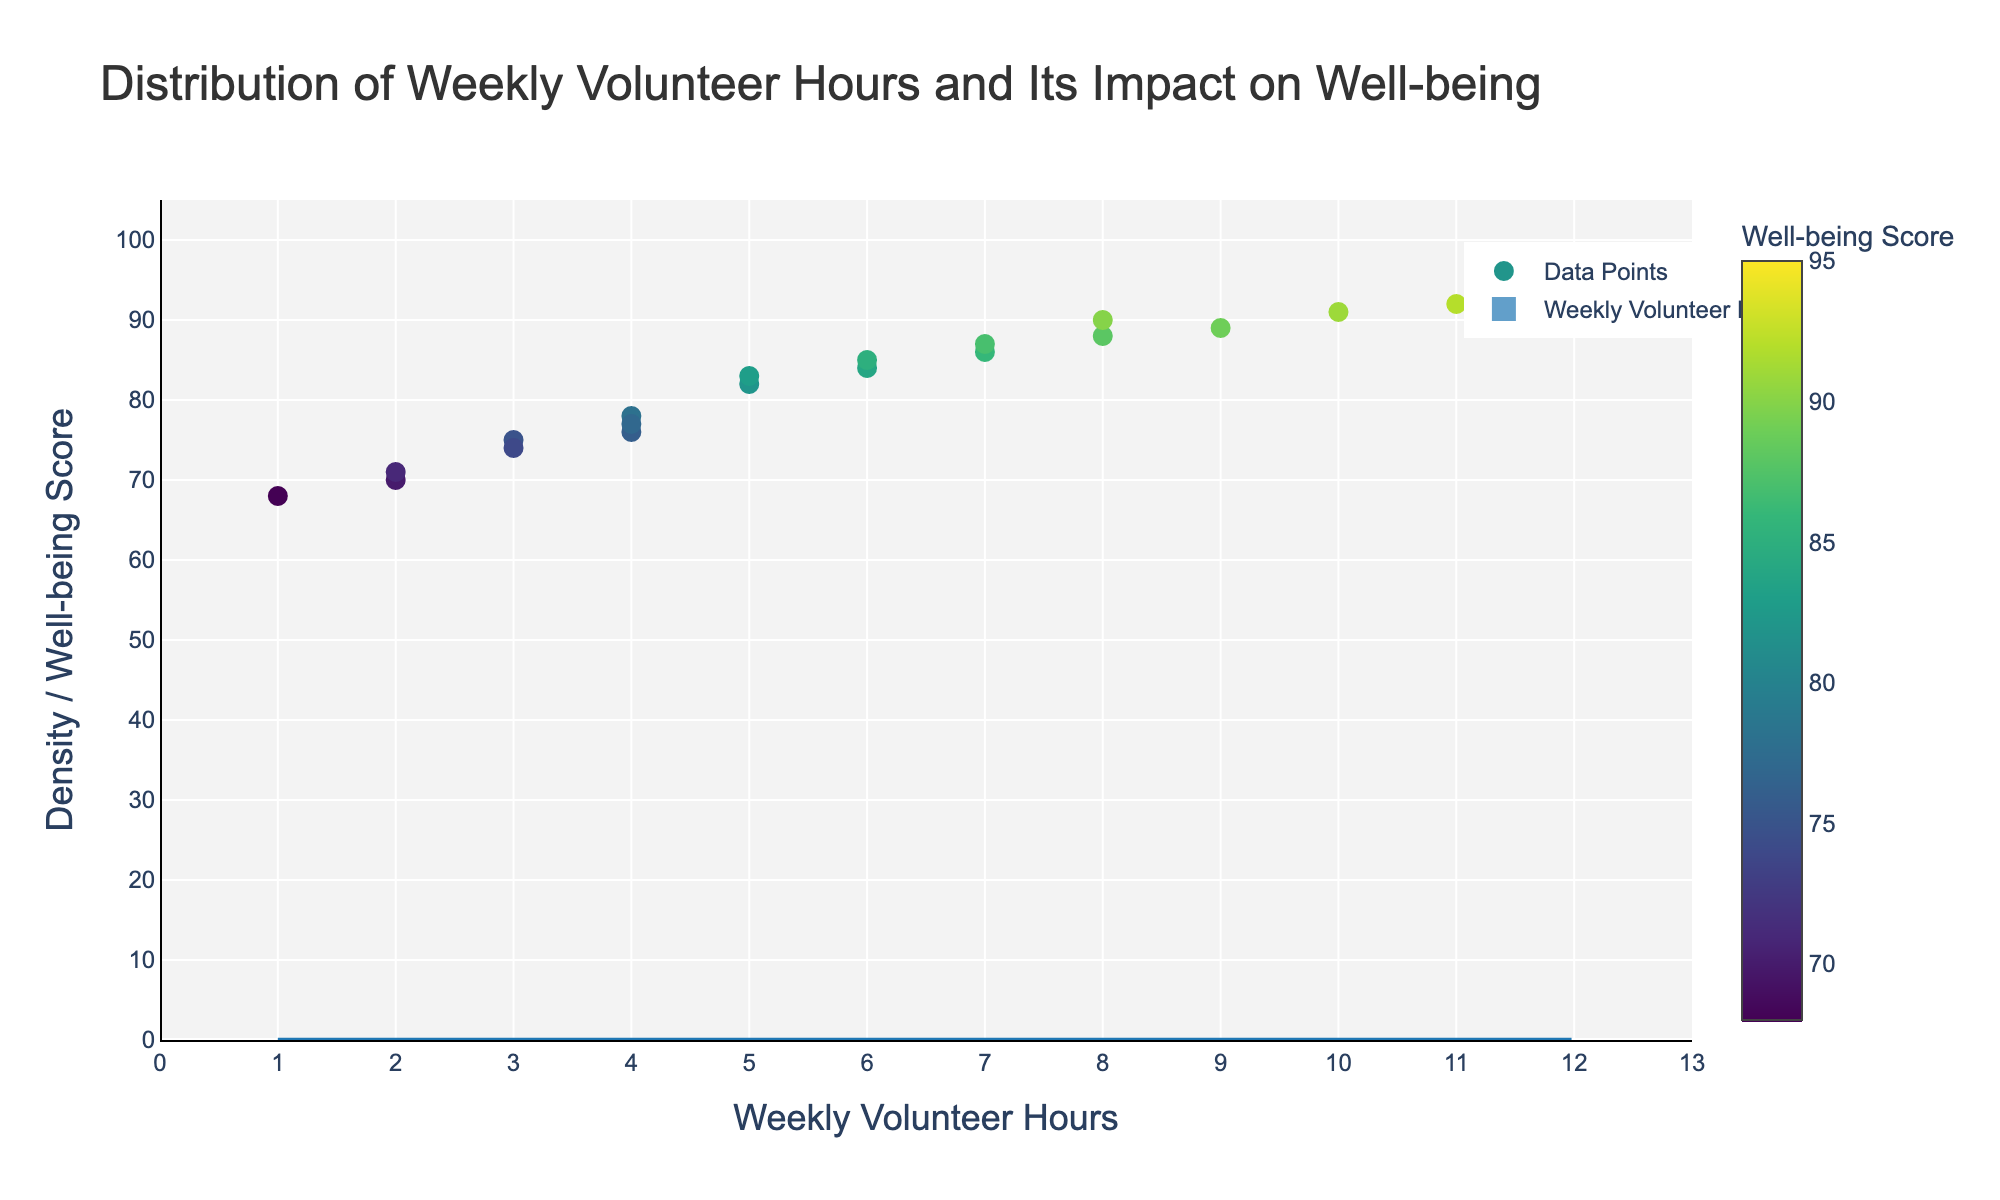What is the title of the plot? The title is typically located at the top center of the plot and provides a brief description of what the plot represents. In this case, it is "Distribution of Weekly Volunteer Hours and Its Impact on Well-being."
Answer: Distribution of Weekly Volunteer Hours and Its Impact on Well-being How many different weekly volunteer hour values are present in the plot? By examining the x-axis and the distinct bins in the histogram, you can count the unique values. They range from 1 to 12.
Answer: 12 What weekly volunteer hour has the highest density? By observing the histogram (blue bars), you can see which volunteer hour value has the tallest bar, indicating the highest density.
Answer: 5 hours What is the range of well-being scores displayed in the scatter plot? The range is determined by identifying the minimum and maximum values on the well-being score color bar, which ranges from 68 to 95.
Answer: 68 to 95 How does volunteer hour correlates with well-being score? By noting the scatter plot points on the graph, as the volunteer hours increase, the well-being scores generally trend upwards, indicating a positive correlation.
Answer: Positive correlation What is the well-being score of the person who volunteers 12 hours per week? By finding the scatter point closest to the x-axis value of 12 and then observing its color on the color scale, you can determine the well-being score.
Answer: 95 Which volunteer hour has the least density? The volunteer hour with the least density will have the shortest bar in the histogram. Here, it is 1 hour.
Answer: 1 hour What weekly volunteer hour value has the second highest density? The second highest density is determined by identifying the bar that is the second tallest in the histogram. Here, it is 4 hours.
Answer: 4 hours Compare the well-being scores of volunteers who work between 1 to 3 hours per week and those who work between 10 to 12 hours per week. Look at the points on the scatter plot within the ranges 1-3 and 10-12 hours, noting their color on the well-being score legend. Volunteers working 1-3 hours are generally in the 70-75 range, while those working 10-12 hours are around 90-95.
Answer: Volunteers working 1-3 hours: 70-75. Volunteers working 10-12 hours: 90-95 Which weekly volunteer hour value has the most significant outlier in terms of well-being score? An outlier is a point that deviates significantly from other observations. By observing the scatter plot, look for the point farthest from others within any volunteer hour bin. For instance, within 6 hours, well-being score is 84, and other points are close to average.
Answer: 6 hours 